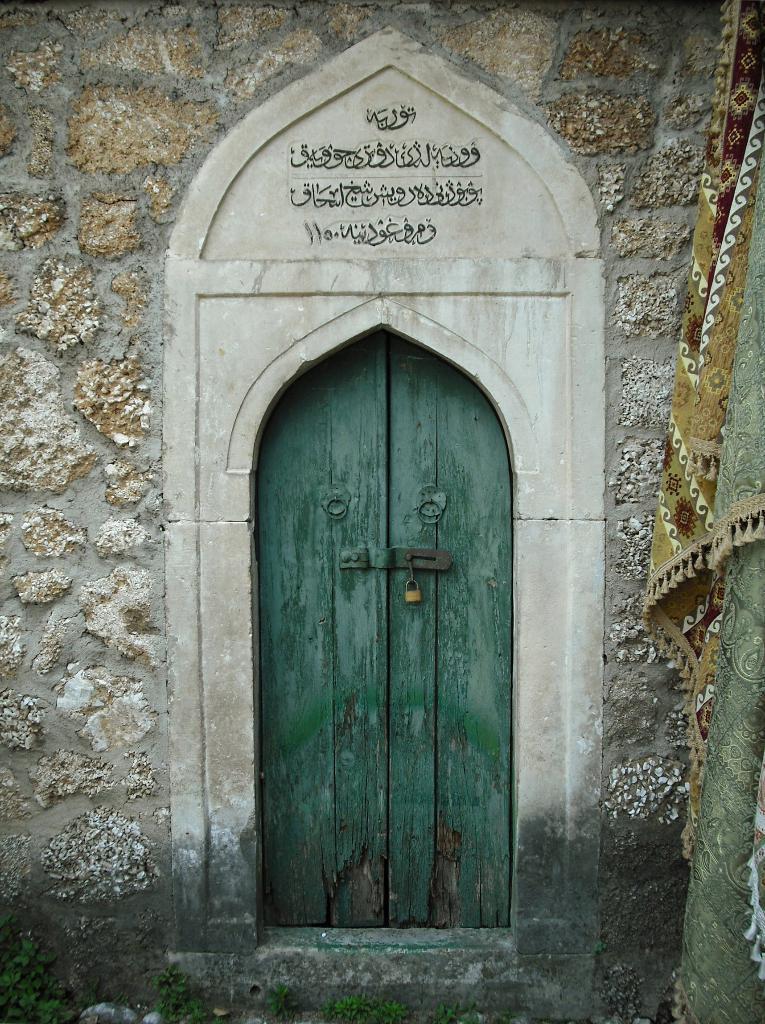Could you give a brief overview of what you see in this image? In this image I can see a wooden door with a lock I can see a marble design around the door with some text. On the right hand side, I can see some clothes hanging. 